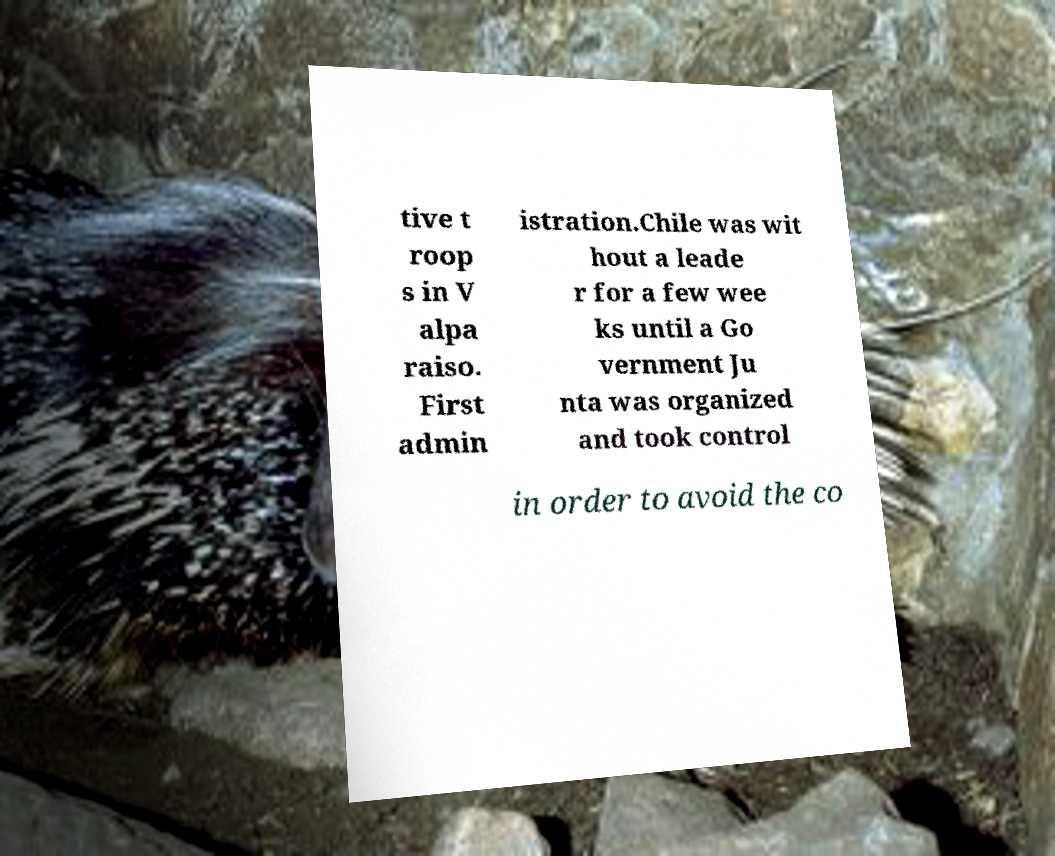Could you extract and type out the text from this image? tive t roop s in V alpa raiso. First admin istration.Chile was wit hout a leade r for a few wee ks until a Go vernment Ju nta was organized and took control in order to avoid the co 